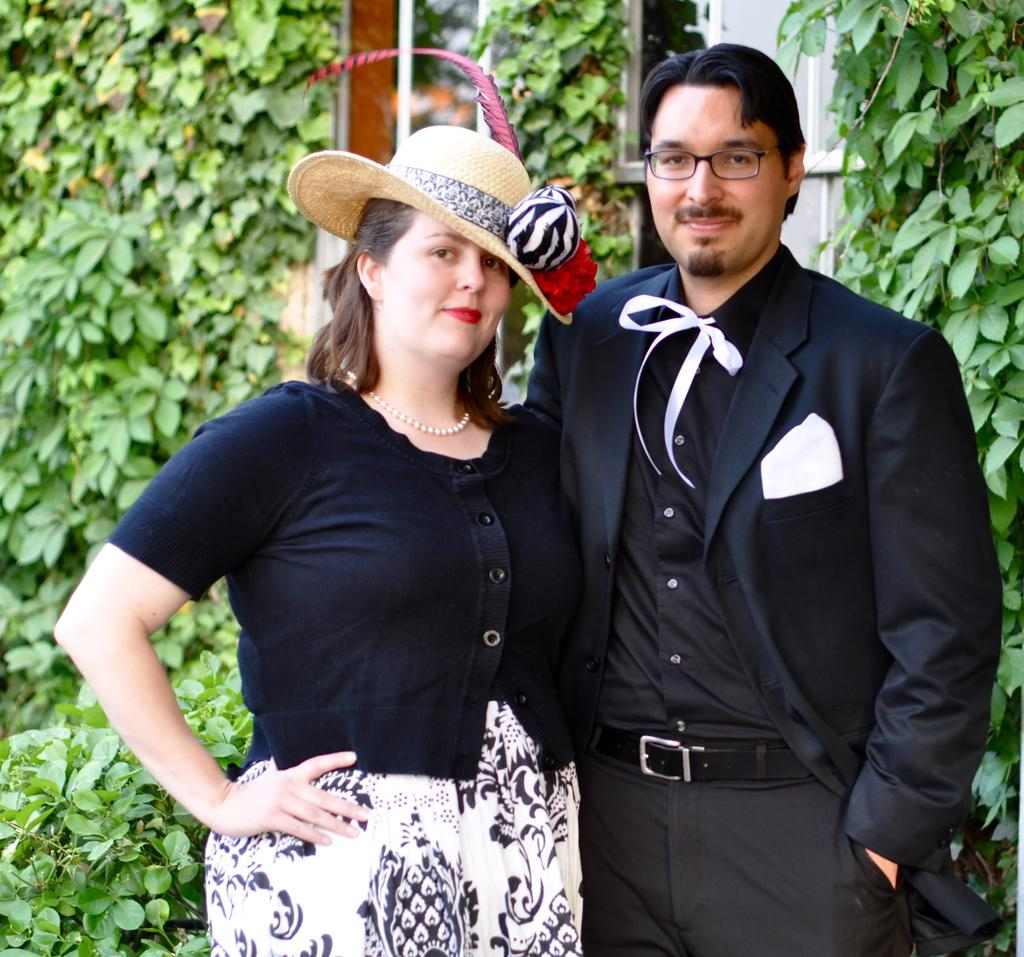Who are the people in the foreground of the picture? There is a couple standing in the foreground of the picture. What are the couple wearing? The couple is wearing black-colored dresses. What can be seen in the middle of the picture? There are plants and an iron frame in the middle of the picture. What type of structure is visible in the middle of the picture? There is a building in the middle of the picture. What type of button can be seen on the secretary's shirt in the image? There is no secretary or button present in the image. What achievements has the achiever in the image accomplished? There is no achiever or mention of achievements in the image. 